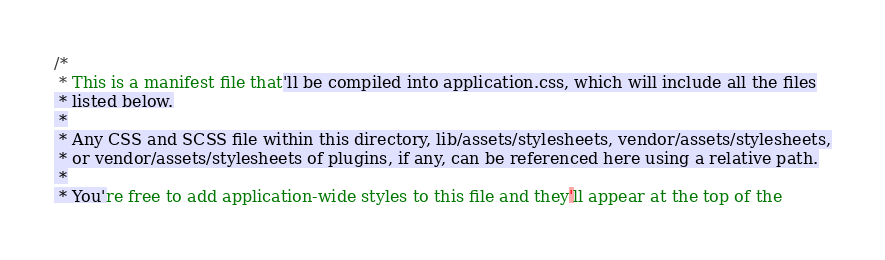Convert code to text. <code><loc_0><loc_0><loc_500><loc_500><_CSS_>/*
 * This is a manifest file that'll be compiled into application.css, which will include all the files
 * listed below.
 *
 * Any CSS and SCSS file within this directory, lib/assets/stylesheets, vendor/assets/stylesheets,
 * or vendor/assets/stylesheets of plugins, if any, can be referenced here using a relative path.
 *
 * You're free to add application-wide styles to this file and they'll appear at the top of the</code> 